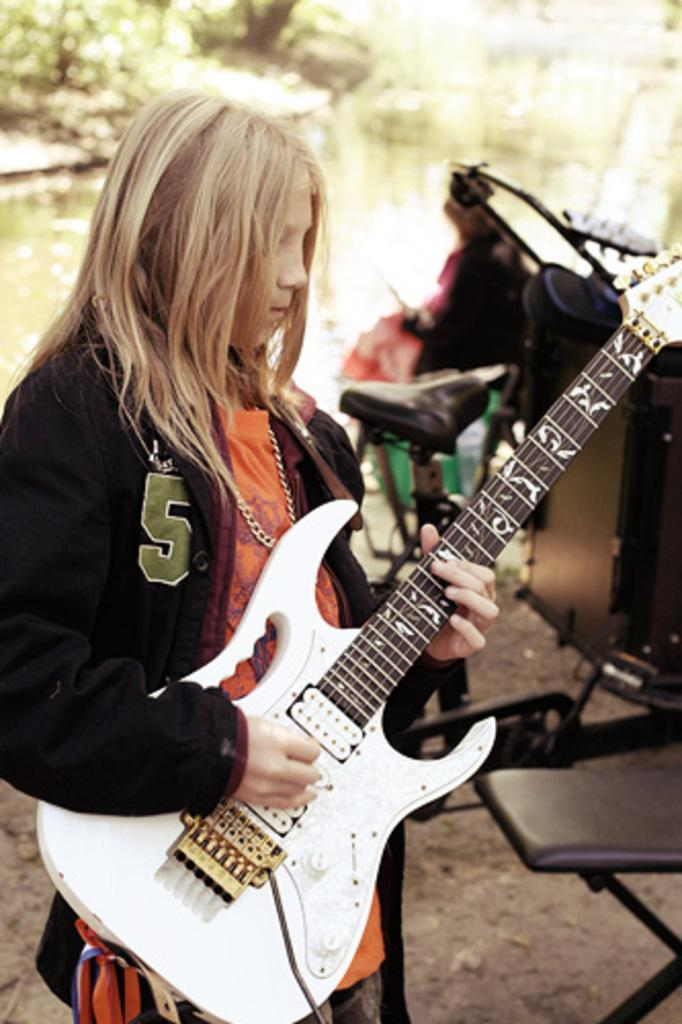What is the person in the image doing? The person is standing in the image and holding a guitar. What might the person be about to do with the guitar? The person might be about to play the guitar. What can be seen to the left of the person? There are objects to the left of the person. What type of natural scenery is visible in the image? There are trees visible in the image. How many boys are playing quietly in the image? There is no reference to boys or quiet playing in the image; it features a person holding a guitar and trees in the background. 